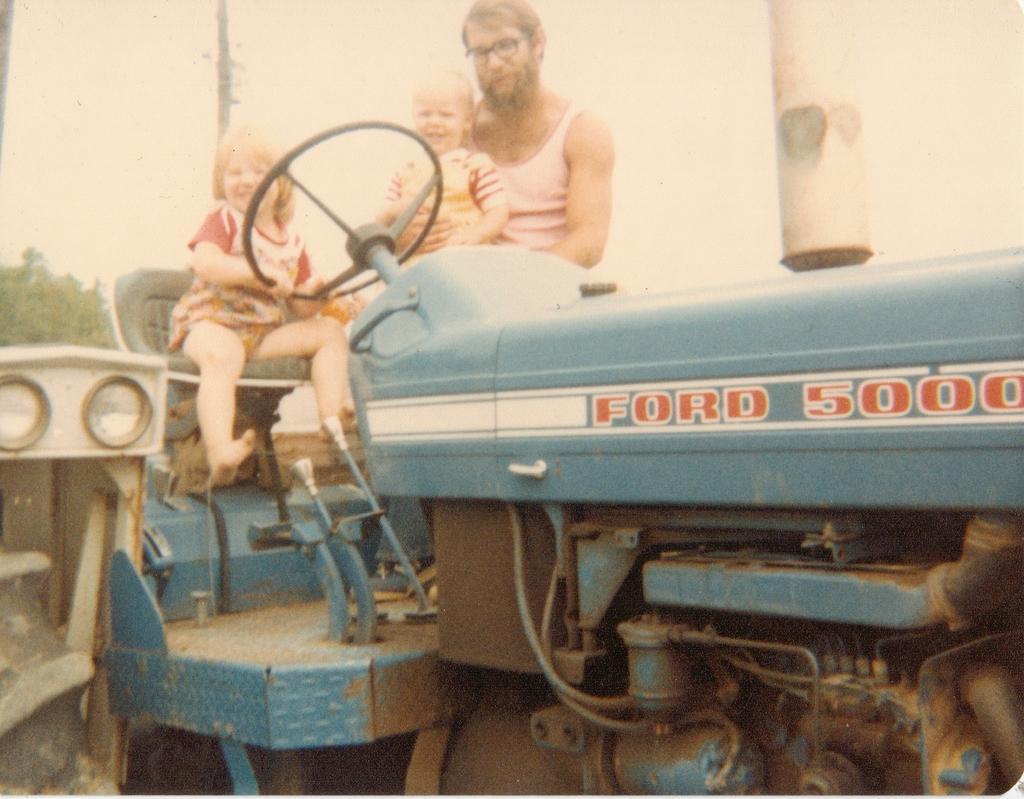Please provide a concise description of this image. In the picture we can see the part of the tractor with a seat on it and we can see a girl is sitting and smiling and beside her we can see a man standing and holding another girl and behind the tractor we can see the part of the tree and the sky. 